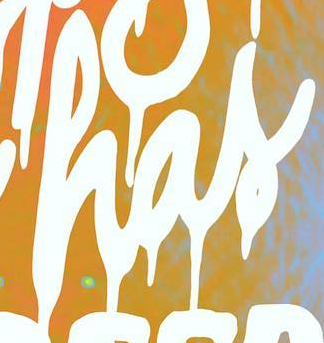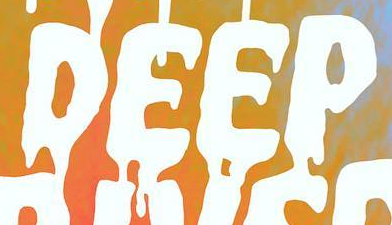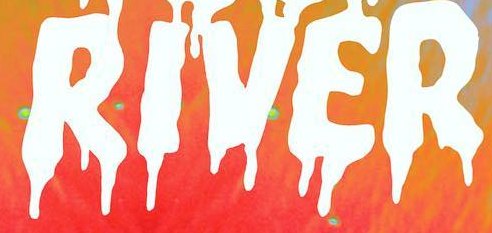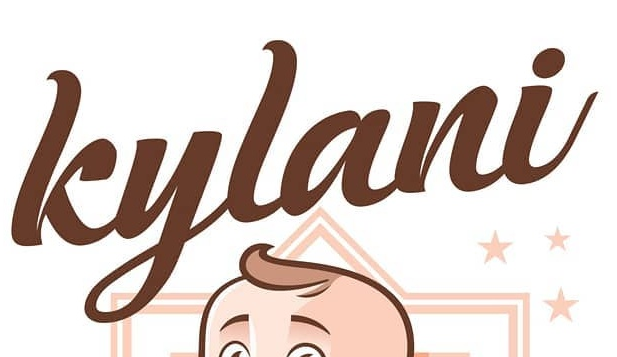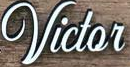What words are shown in these images in order, separated by a semicolon? has; DEEP; RIVER; kylani; Victor 